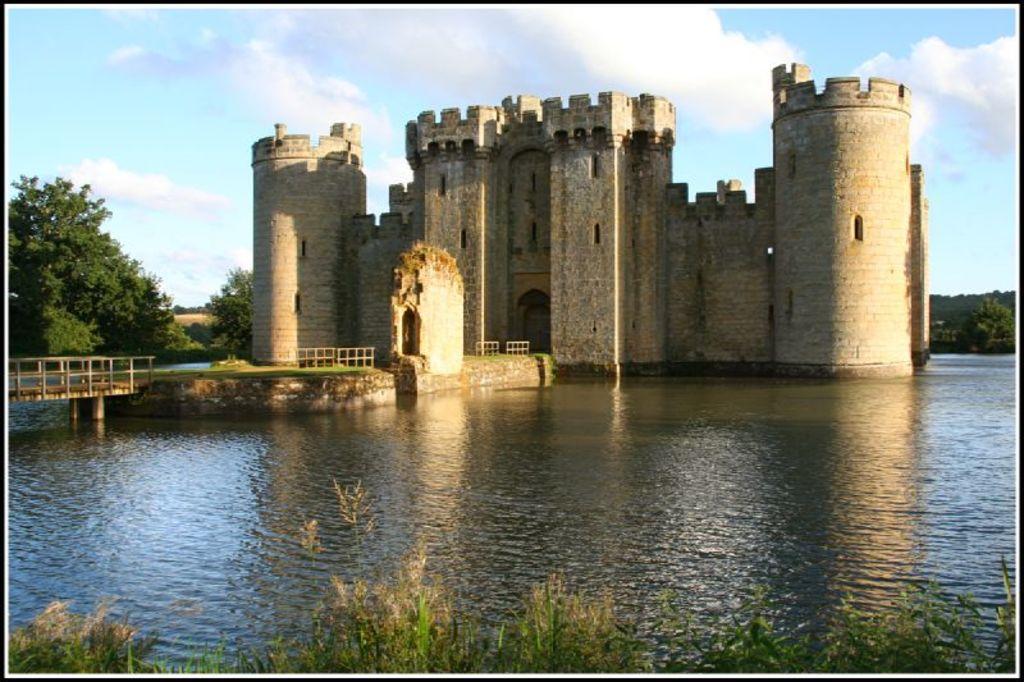Describe this image in one or two sentences. This is water. Here we can see a fence, trees, grass, and ancient architecture. In the background we can see sky with clouds. 